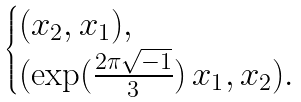<formula> <loc_0><loc_0><loc_500><loc_500>\begin{cases} ( x _ { 2 } , x _ { 1 } ) , \\ ( \exp ( \frac { 2 \pi \sqrt { - 1 } } { 3 } ) \, x _ { 1 } , x _ { 2 } ) . \end{cases}</formula> 